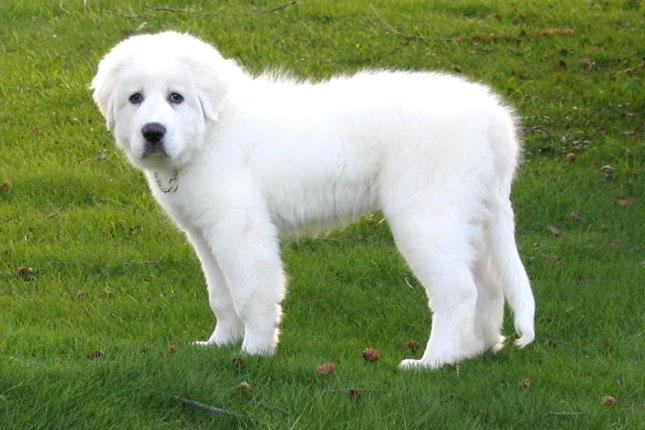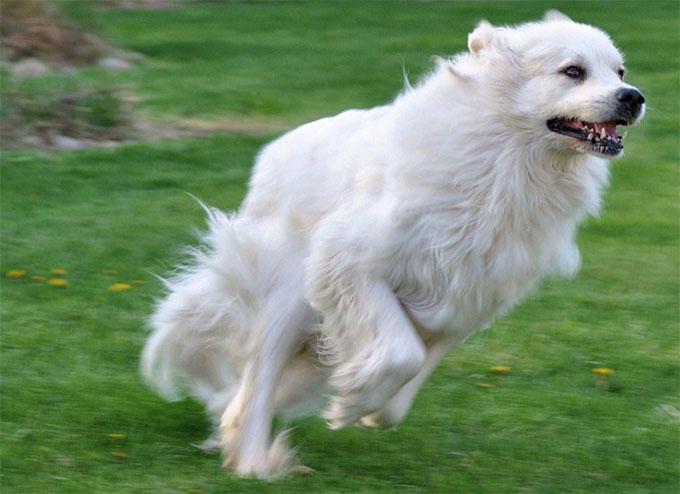The first image is the image on the left, the second image is the image on the right. Analyze the images presented: Is the assertion "Left image shows fluffy dog standing on green grass." valid? Answer yes or no. Yes. The first image is the image on the left, the second image is the image on the right. Analyze the images presented: Is the assertion "One of the dogs is standing in a side profile pose." valid? Answer yes or no. Yes. 